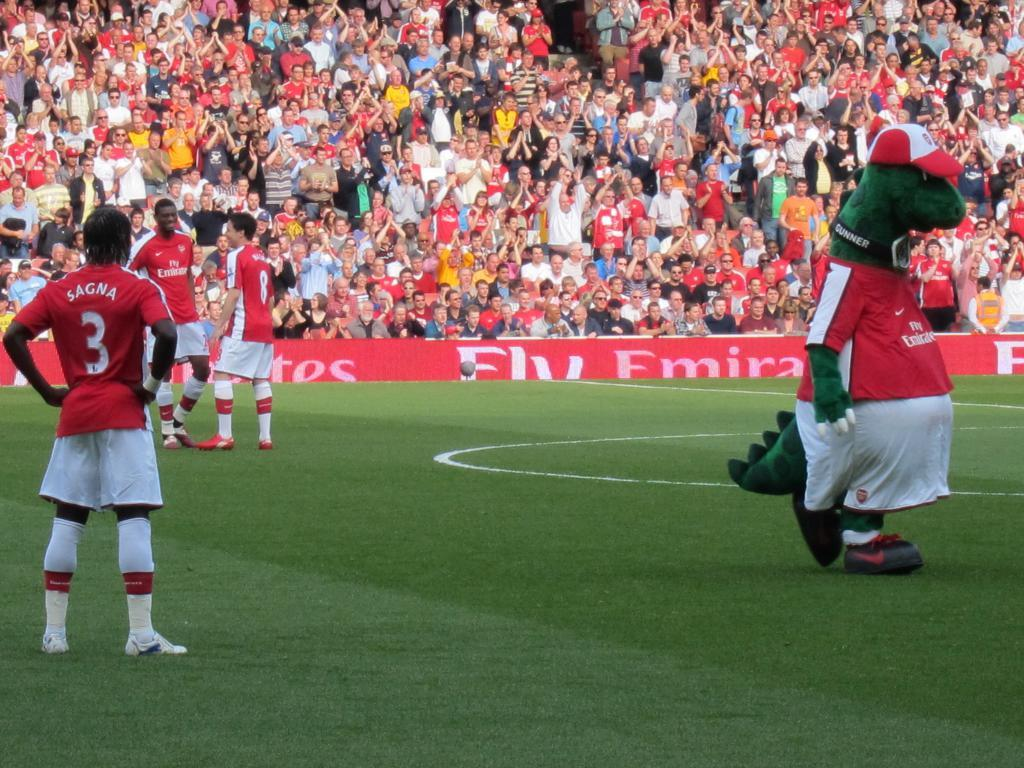How many people are in the image? There is a group of people in the image, but the exact number is not specified. What are the people in the image doing? Some people are seated, while others are standing. What can be seen on the hoardings in the image? The content of the hoardings is not mentioned in the facts. What type of surface is visible in the image? Grass is present in the image. Can you tell me the angle at which the hen is standing in the image? There is no hen present in the image. How does the group of people plan to change their seating arrangement during the event? The facts do not mention any plans for changing the seating arrangement, nor is there any information about an event taking place. 